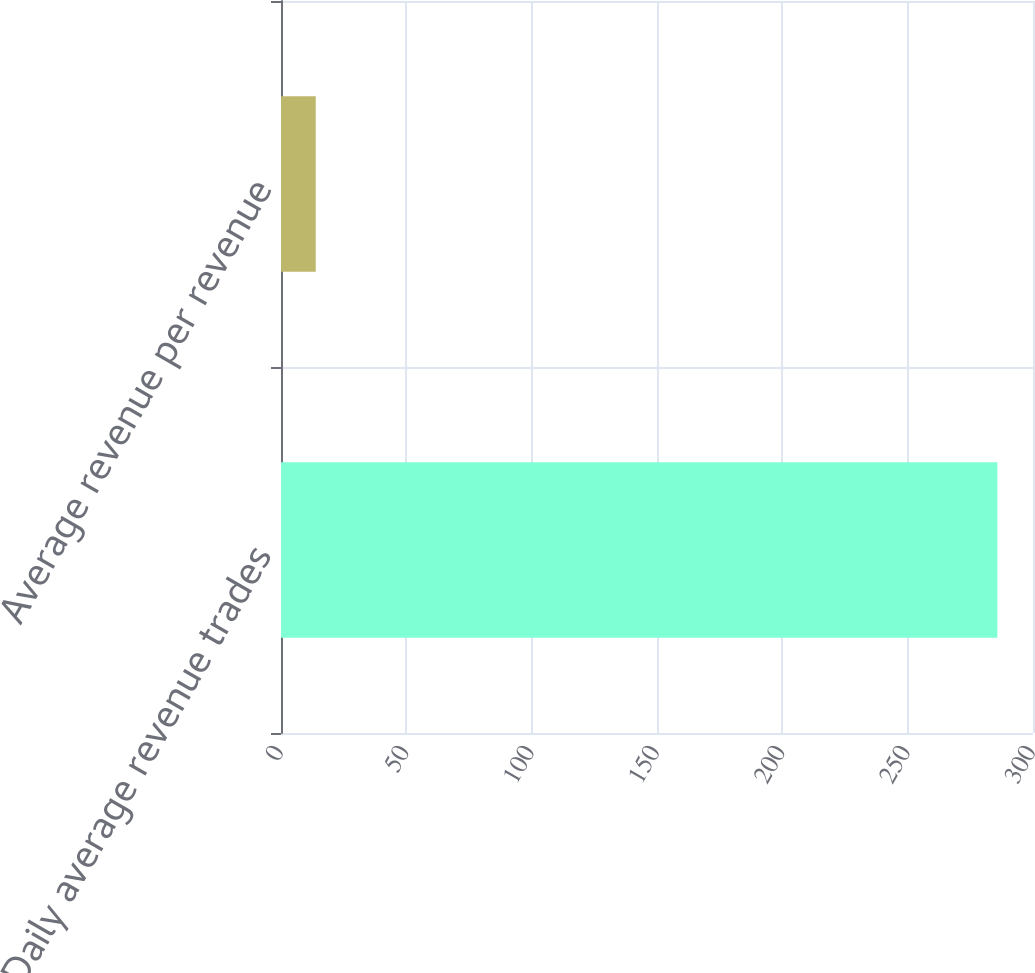Convert chart. <chart><loc_0><loc_0><loc_500><loc_500><bar_chart><fcel>Daily average revenue trades<fcel>Average revenue per revenue<nl><fcel>285.8<fcel>13.86<nl></chart> 